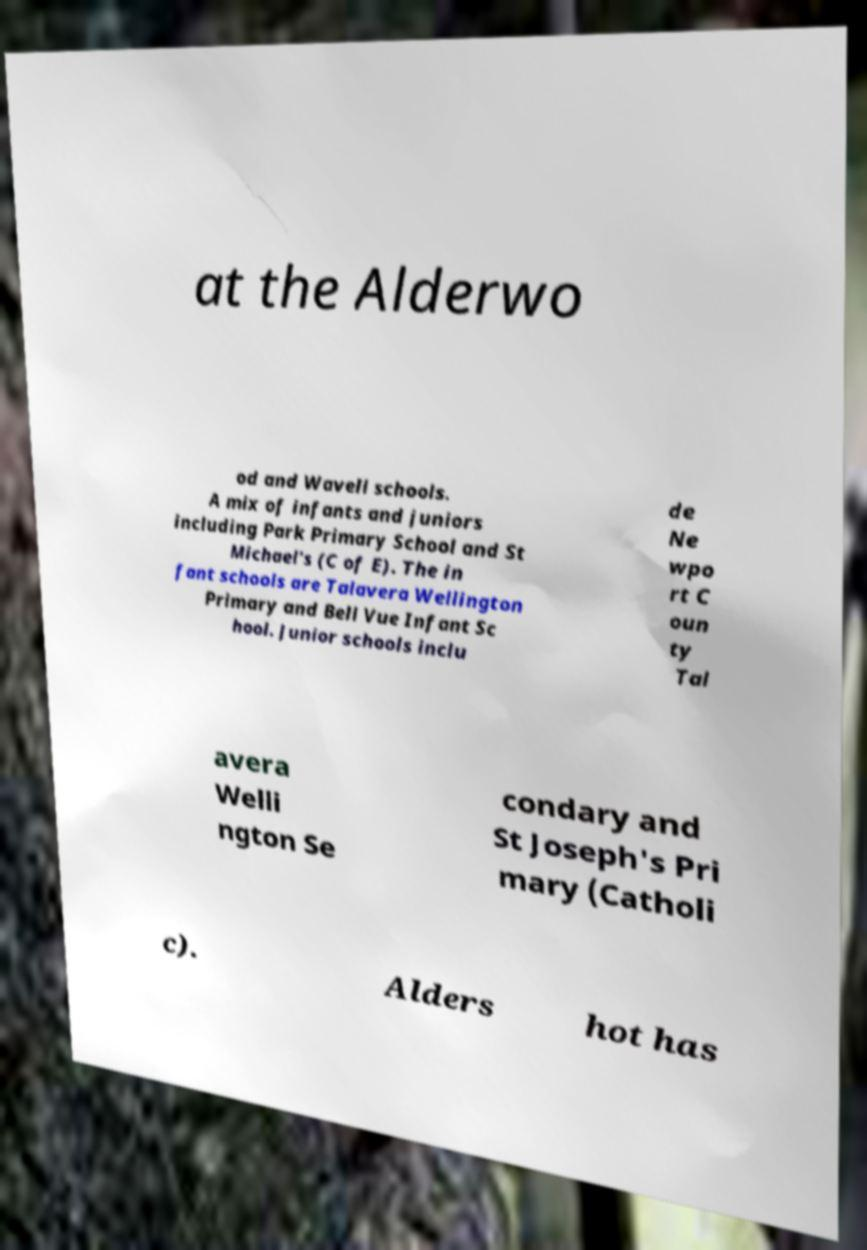Can you read and provide the text displayed in the image?This photo seems to have some interesting text. Can you extract and type it out for me? at the Alderwo od and Wavell schools. A mix of infants and juniors including Park Primary School and St Michael's (C of E). The in fant schools are Talavera Wellington Primary and Bell Vue Infant Sc hool. Junior schools inclu de Ne wpo rt C oun ty Tal avera Welli ngton Se condary and St Joseph's Pri mary (Catholi c). Alders hot has 